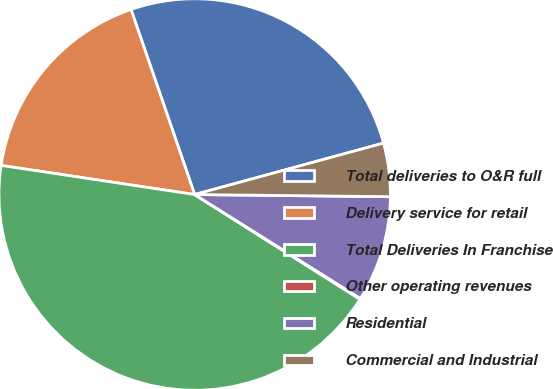<chart> <loc_0><loc_0><loc_500><loc_500><pie_chart><fcel>Total deliveries to O&R full<fcel>Delivery service for retail<fcel>Total Deliveries In Franchise<fcel>Other operating revenues<fcel>Residential<fcel>Commercial and Industrial<nl><fcel>26.04%<fcel>17.35%<fcel>43.39%<fcel>0.07%<fcel>8.74%<fcel>4.41%<nl></chart> 